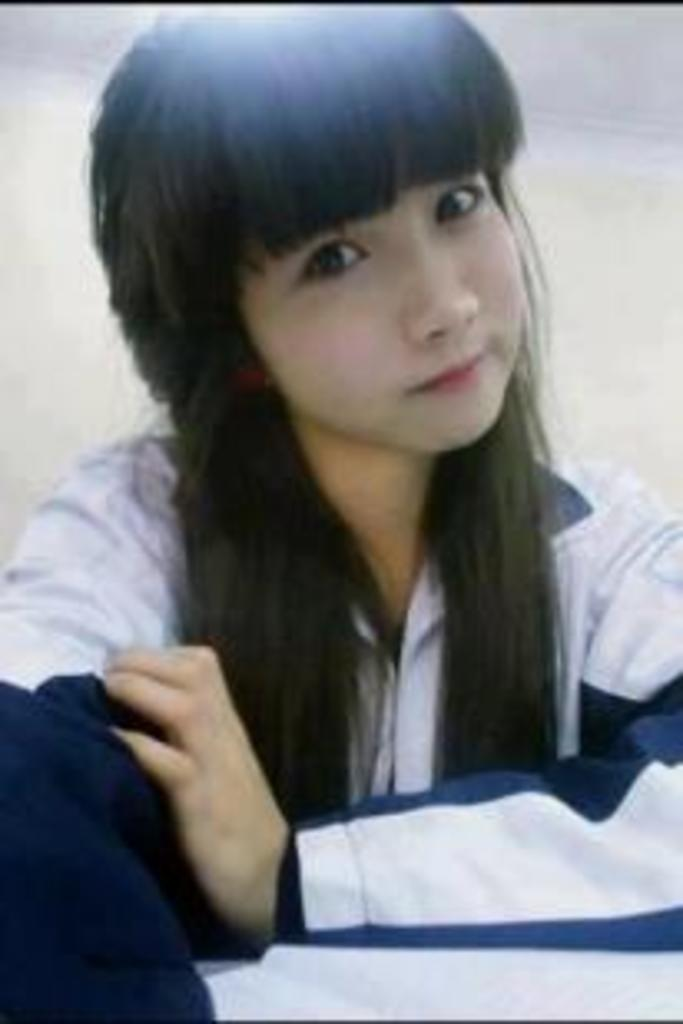Who is present in the image? There is a woman in the image. What can be seen behind the woman? The background of the image is white. What level of expertise does the woman have with a rail and whistle in the image? There is no rail or whistle present in the image, so it is not possible to determine the woman's level of expertise with these items. 